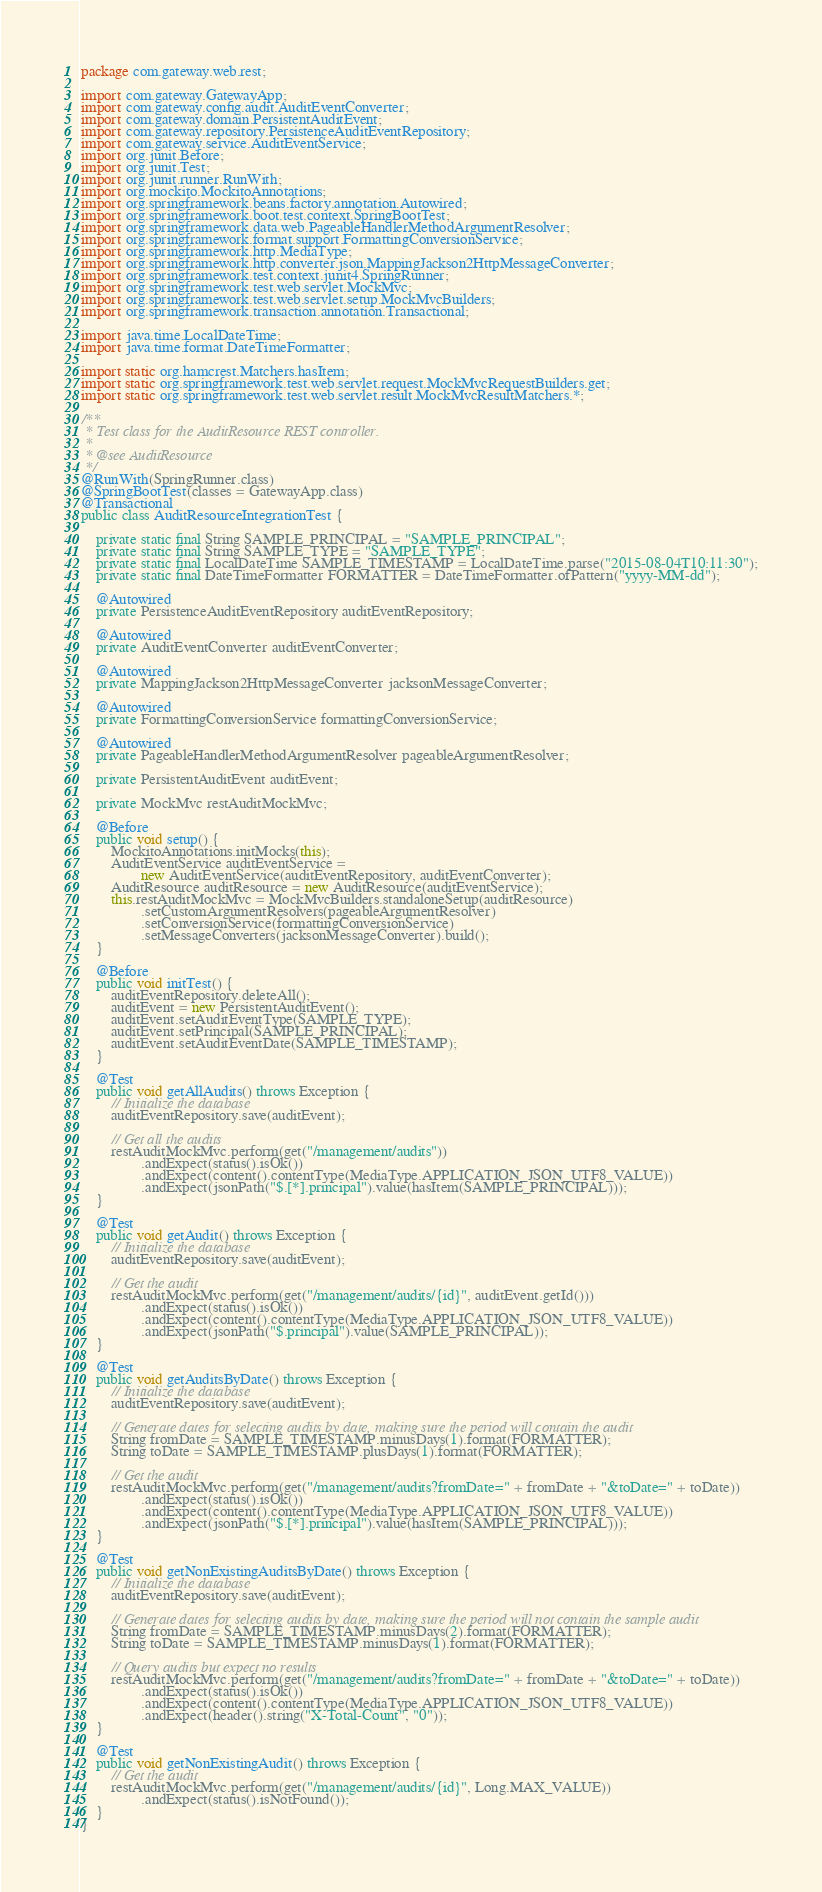Convert code to text. <code><loc_0><loc_0><loc_500><loc_500><_Java_>package com.gateway.web.rest;

import com.gateway.GatewayApp;
import com.gateway.config.audit.AuditEventConverter;
import com.gateway.domain.PersistentAuditEvent;
import com.gateway.repository.PersistenceAuditEventRepository;
import com.gateway.service.AuditEventService;
import org.junit.Before;
import org.junit.Test;
import org.junit.runner.RunWith;
import org.mockito.MockitoAnnotations;
import org.springframework.beans.factory.annotation.Autowired;
import org.springframework.boot.test.context.SpringBootTest;
import org.springframework.data.web.PageableHandlerMethodArgumentResolver;
import org.springframework.format.support.FormattingConversionService;
import org.springframework.http.MediaType;
import org.springframework.http.converter.json.MappingJackson2HttpMessageConverter;
import org.springframework.test.context.junit4.SpringRunner;
import org.springframework.test.web.servlet.MockMvc;
import org.springframework.test.web.servlet.setup.MockMvcBuilders;
import org.springframework.transaction.annotation.Transactional;

import java.time.LocalDateTime;
import java.time.format.DateTimeFormatter;

import static org.hamcrest.Matchers.hasItem;
import static org.springframework.test.web.servlet.request.MockMvcRequestBuilders.get;
import static org.springframework.test.web.servlet.result.MockMvcResultMatchers.*;

/**
 * Test class for the AuditResource REST controller.
 *
 * @see AuditResource
 */
@RunWith(SpringRunner.class)
@SpringBootTest(classes = GatewayApp.class)
@Transactional
public class AuditResourceIntegrationTest {

    private static final String SAMPLE_PRINCIPAL = "SAMPLE_PRINCIPAL";
    private static final String SAMPLE_TYPE = "SAMPLE_TYPE";
    private static final LocalDateTime SAMPLE_TIMESTAMP = LocalDateTime.parse("2015-08-04T10:11:30");
    private static final DateTimeFormatter FORMATTER = DateTimeFormatter.ofPattern("yyyy-MM-dd");

    @Autowired
    private PersistenceAuditEventRepository auditEventRepository;

    @Autowired
    private AuditEventConverter auditEventConverter;

    @Autowired
    private MappingJackson2HttpMessageConverter jacksonMessageConverter;

    @Autowired
    private FormattingConversionService formattingConversionService;

    @Autowired
    private PageableHandlerMethodArgumentResolver pageableArgumentResolver;

    private PersistentAuditEvent auditEvent;

    private MockMvc restAuditMockMvc;

    @Before
    public void setup() {
        MockitoAnnotations.initMocks(this);
        AuditEventService auditEventService =
                new AuditEventService(auditEventRepository, auditEventConverter);
        AuditResource auditResource = new AuditResource(auditEventService);
        this.restAuditMockMvc = MockMvcBuilders.standaloneSetup(auditResource)
                .setCustomArgumentResolvers(pageableArgumentResolver)
                .setConversionService(formattingConversionService)
                .setMessageConverters(jacksonMessageConverter).build();
    }

    @Before
    public void initTest() {
        auditEventRepository.deleteAll();
        auditEvent = new PersistentAuditEvent();
        auditEvent.setAuditEventType(SAMPLE_TYPE);
        auditEvent.setPrincipal(SAMPLE_PRINCIPAL);
        auditEvent.setAuditEventDate(SAMPLE_TIMESTAMP);
    }

    @Test
    public void getAllAudits() throws Exception {
        // Initialize the database
        auditEventRepository.save(auditEvent);

        // Get all the audits
        restAuditMockMvc.perform(get("/management/audits"))
                .andExpect(status().isOk())
                .andExpect(content().contentType(MediaType.APPLICATION_JSON_UTF8_VALUE))
                .andExpect(jsonPath("$.[*].principal").value(hasItem(SAMPLE_PRINCIPAL)));
    }

    @Test
    public void getAudit() throws Exception {
        // Initialize the database
        auditEventRepository.save(auditEvent);

        // Get the audit
        restAuditMockMvc.perform(get("/management/audits/{id}", auditEvent.getId()))
                .andExpect(status().isOk())
                .andExpect(content().contentType(MediaType.APPLICATION_JSON_UTF8_VALUE))
                .andExpect(jsonPath("$.principal").value(SAMPLE_PRINCIPAL));
    }

    @Test
    public void getAuditsByDate() throws Exception {
        // Initialize the database
        auditEventRepository.save(auditEvent);

        // Generate dates for selecting audits by date, making sure the period will contain the audit
        String fromDate = SAMPLE_TIMESTAMP.minusDays(1).format(FORMATTER);
        String toDate = SAMPLE_TIMESTAMP.plusDays(1).format(FORMATTER);

        // Get the audit
        restAuditMockMvc.perform(get("/management/audits?fromDate=" + fromDate + "&toDate=" + toDate))
                .andExpect(status().isOk())
                .andExpect(content().contentType(MediaType.APPLICATION_JSON_UTF8_VALUE))
                .andExpect(jsonPath("$.[*].principal").value(hasItem(SAMPLE_PRINCIPAL)));
    }

    @Test
    public void getNonExistingAuditsByDate() throws Exception {
        // Initialize the database
        auditEventRepository.save(auditEvent);

        // Generate dates for selecting audits by date, making sure the period will not contain the sample audit
        String fromDate = SAMPLE_TIMESTAMP.minusDays(2).format(FORMATTER);
        String toDate = SAMPLE_TIMESTAMP.minusDays(1).format(FORMATTER);

        // Query audits but expect no results
        restAuditMockMvc.perform(get("/management/audits?fromDate=" + fromDate + "&toDate=" + toDate))
                .andExpect(status().isOk())
                .andExpect(content().contentType(MediaType.APPLICATION_JSON_UTF8_VALUE))
                .andExpect(header().string("X-Total-Count", "0"));
    }

    @Test
    public void getNonExistingAudit() throws Exception {
        // Get the audit
        restAuditMockMvc.perform(get("/management/audits/{id}", Long.MAX_VALUE))
                .andExpect(status().isNotFound());
    }
}
</code> 